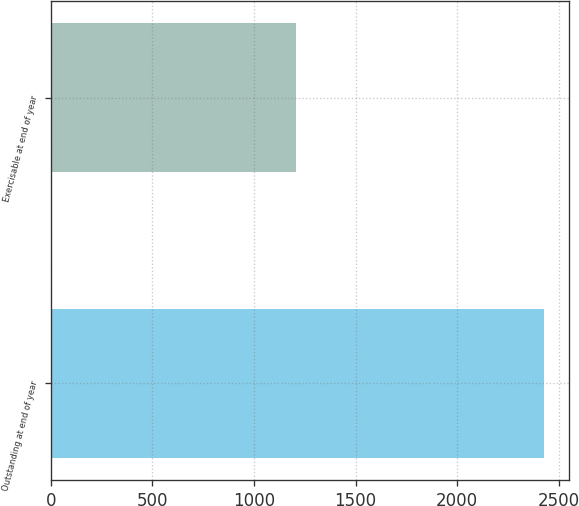Convert chart. <chart><loc_0><loc_0><loc_500><loc_500><bar_chart><fcel>Outstanding at end of year<fcel>Exercisable at end of year<nl><fcel>2429<fcel>1206<nl></chart> 